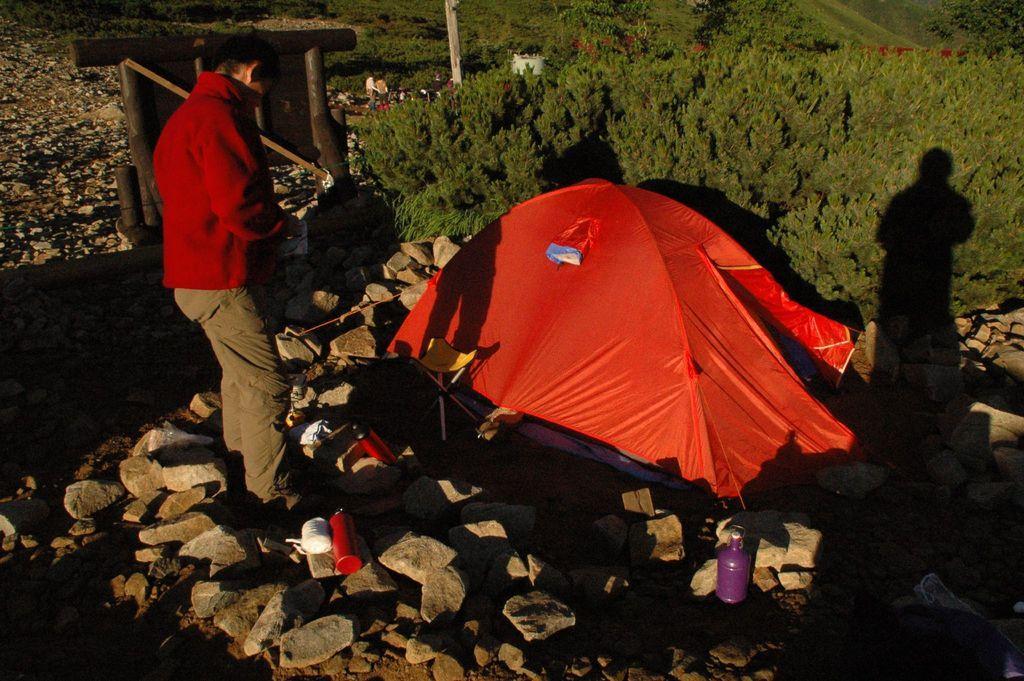Can you describe this image briefly? There is a person standing. On the ground there are bottles and rocks. Also there is a tent. In the back there are trees. 